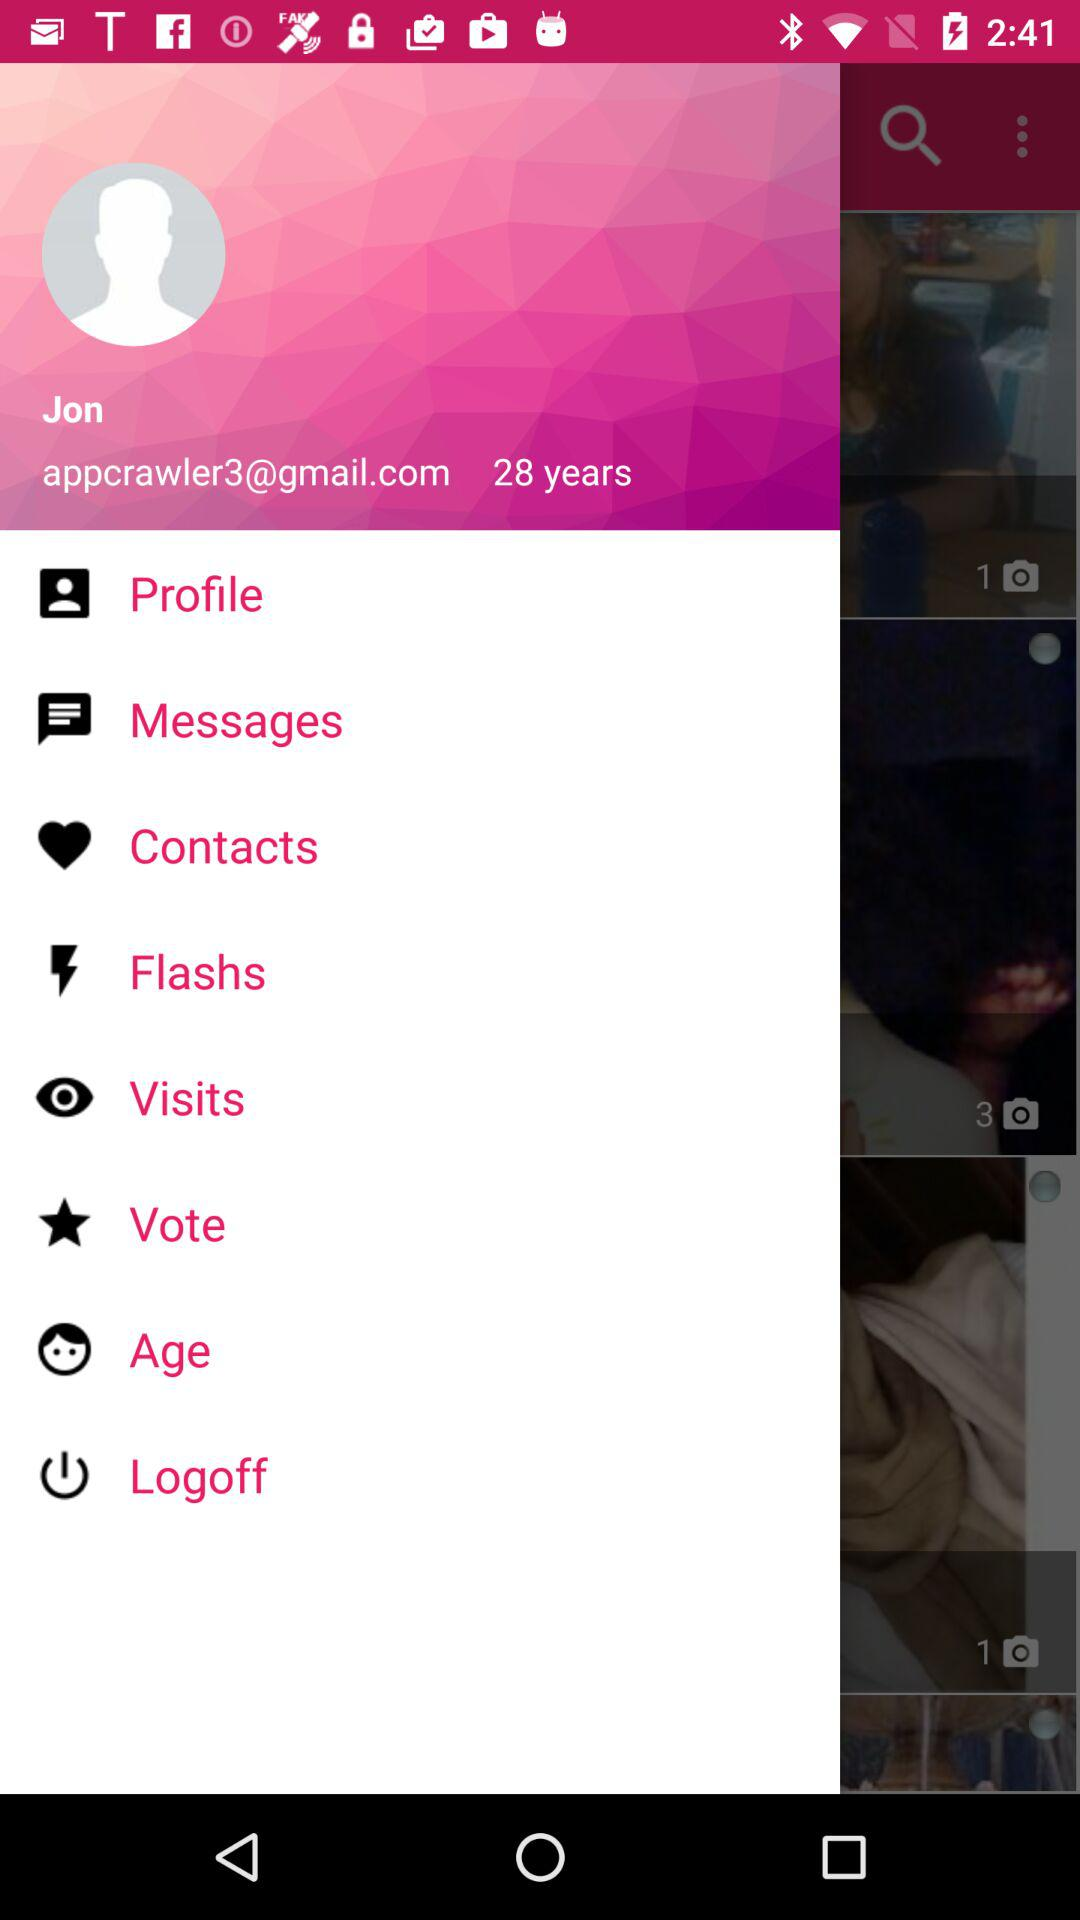How many items have a screenshot?
Answer the question using a single word or phrase. 3 